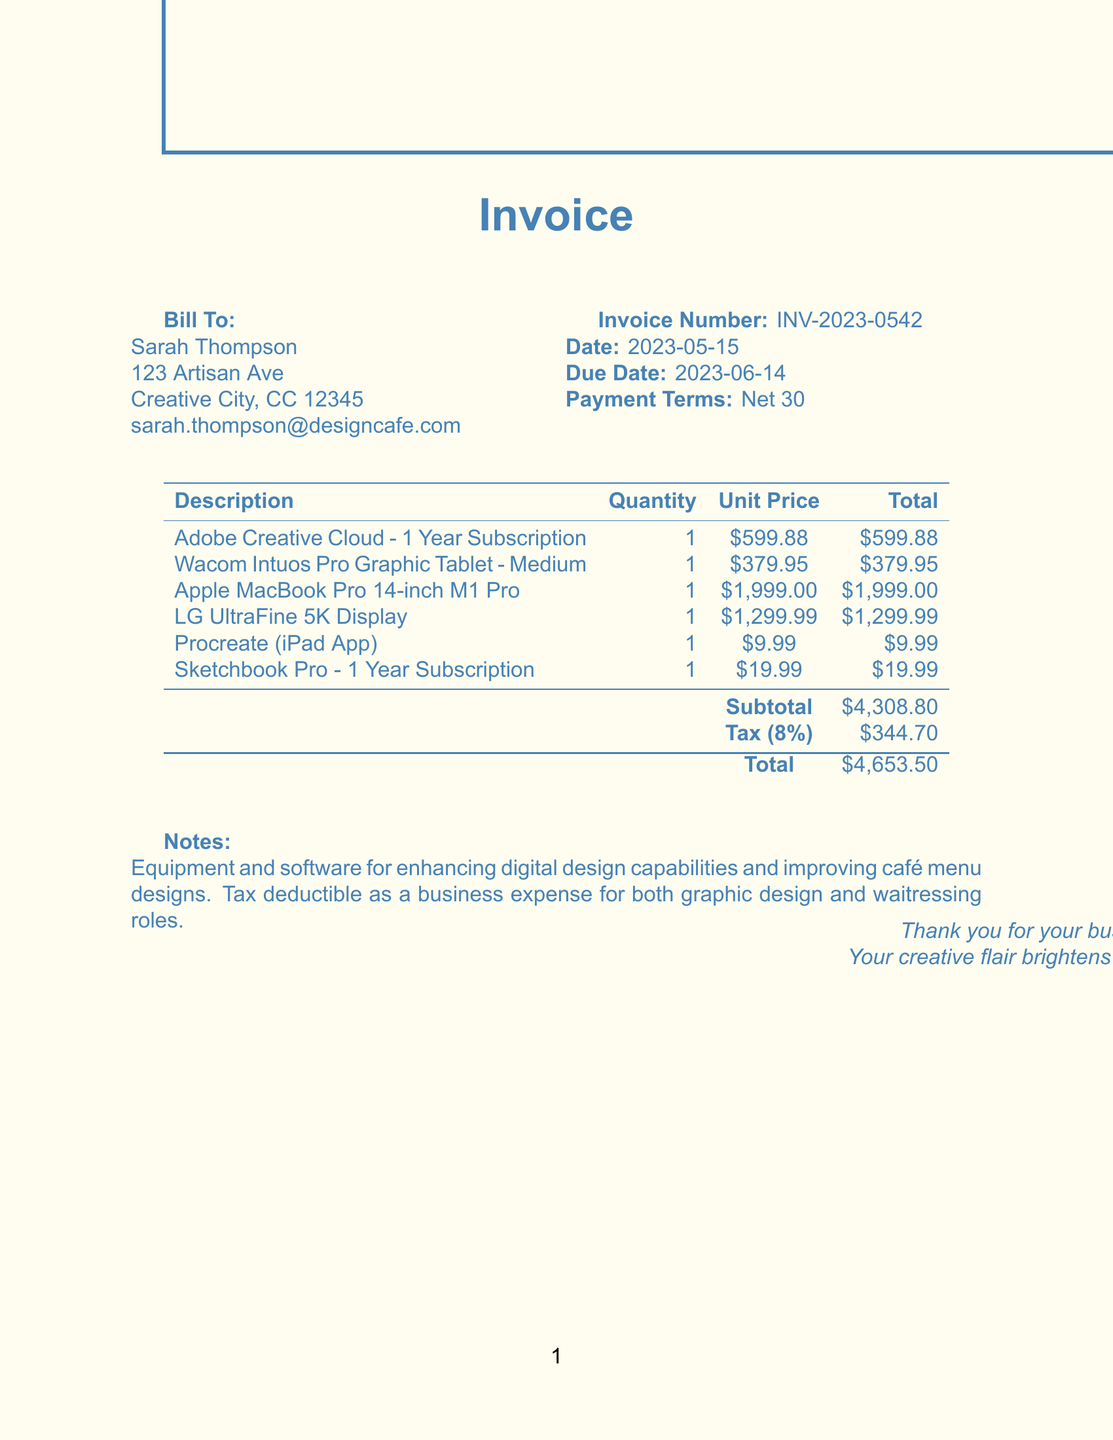What is the invoice number? The invoice number is specified in the document to uniquely identify this transaction.
Answer: INV-2023-0542 What is the date of the invoice? The date indicates when the invoice was issued.
Answer: 2023-05-15 Who is the bill to? The document provides the name of the person responsible for the payment.
Answer: Sarah Thompson What is the total amount due? The total amount indicates how much is required to be paid by the due date.
Answer: 4653.50 What is the subtotal before tax? The subtotal is the sum of all itemized costs before applying tax.
Answer: 4308.80 What is the tax rate applied? The document lists the percentage of tax that is applied to the subtotal.
Answer: 8% What is the payment terms? The payment terms specify when the payment is due for the invoice.
Answer: Net 30 What is the purpose of this invoice? The notes section explains the main reason for the purchase stated in the invoice.
Answer: Enhancing digital design capabilities How many items are listed in the invoice? The document itemizes all the products included in the total cost.
Answer: 6 What is the due date for this invoice? The due date indicates when the payment must be made to avoid penalties.
Answer: 2023-06-14 